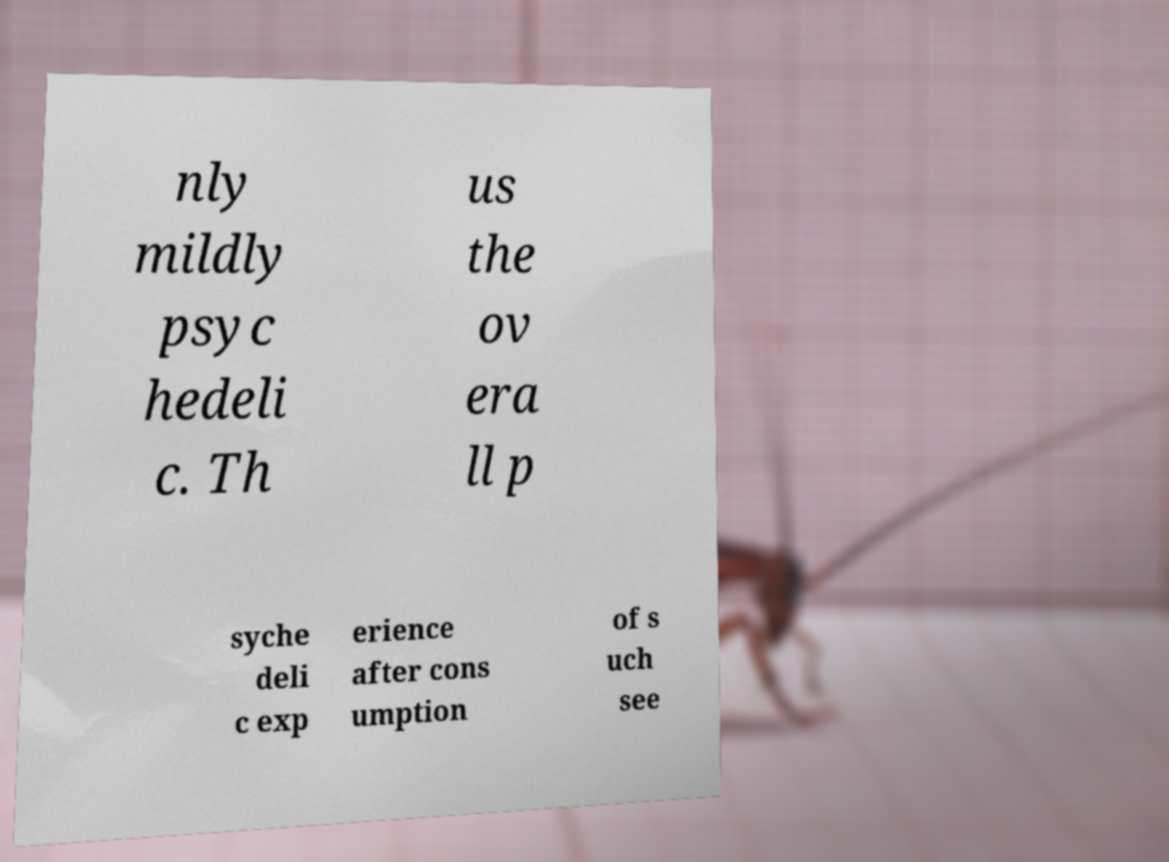Could you assist in decoding the text presented in this image and type it out clearly? nly mildly psyc hedeli c. Th us the ov era ll p syche deli c exp erience after cons umption of s uch see 